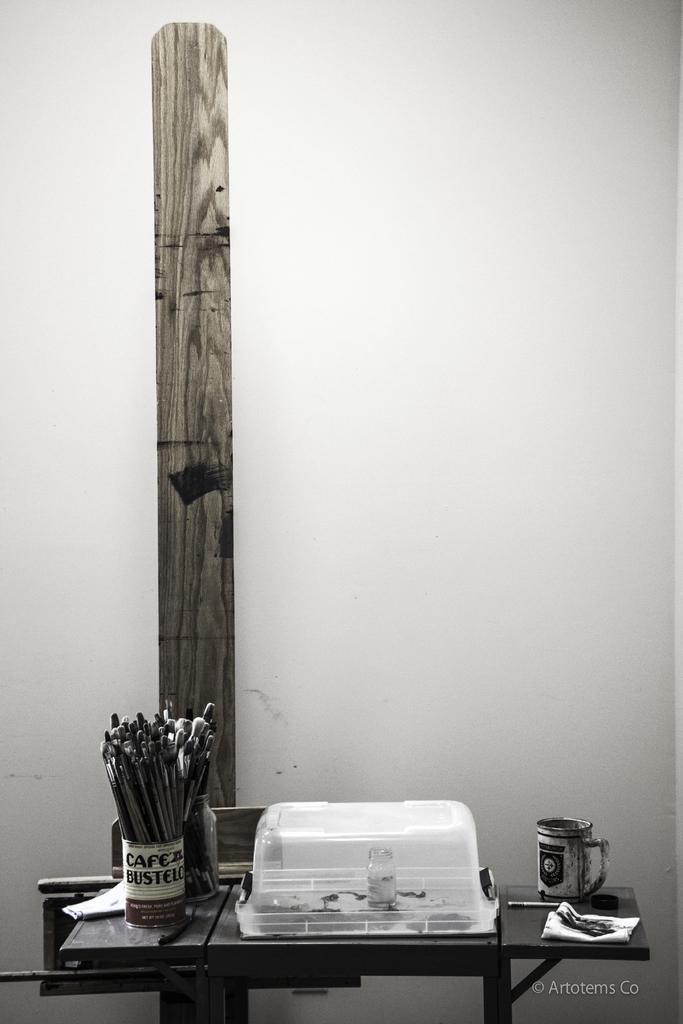Can you describe this image briefly? In this picture I can see penguins in the cup and I can see a box and another cup on the table and I can see text at the bottom right corner of the picture and I can see a wooden plank and a plain background. 